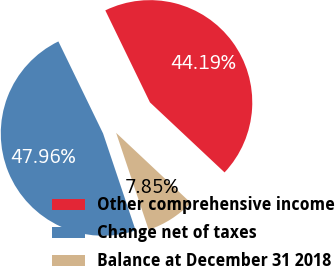Convert chart. <chart><loc_0><loc_0><loc_500><loc_500><pie_chart><fcel>Other comprehensive income<fcel>Change net of taxes<fcel>Balance at December 31 2018<nl><fcel>44.19%<fcel>47.96%<fcel>7.85%<nl></chart> 